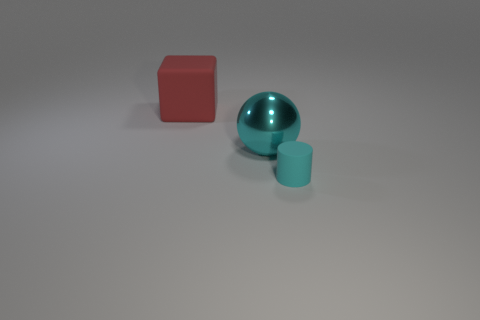Is there anything else of the same color as the large matte block?
Ensure brevity in your answer.  No. What shape is the object that is the same size as the red block?
Keep it short and to the point. Sphere. Does the big metallic object have the same shape as the tiny object?
Your answer should be compact. No. How many other tiny cyan matte things have the same shape as the tiny cyan object?
Your answer should be very brief. 0. There is a big cyan ball; what number of big cyan spheres are in front of it?
Your answer should be compact. 0. Is the color of the object right of the cyan metallic thing the same as the big sphere?
Offer a terse response. Yes. What number of blue metallic balls are the same size as the cyan ball?
Provide a short and direct response. 0. The large object that is the same material as the tiny cyan object is what shape?
Ensure brevity in your answer.  Cube. Is there a big metallic ball of the same color as the cube?
Provide a short and direct response. No. What is the material of the small cyan cylinder?
Your answer should be very brief. Rubber. 